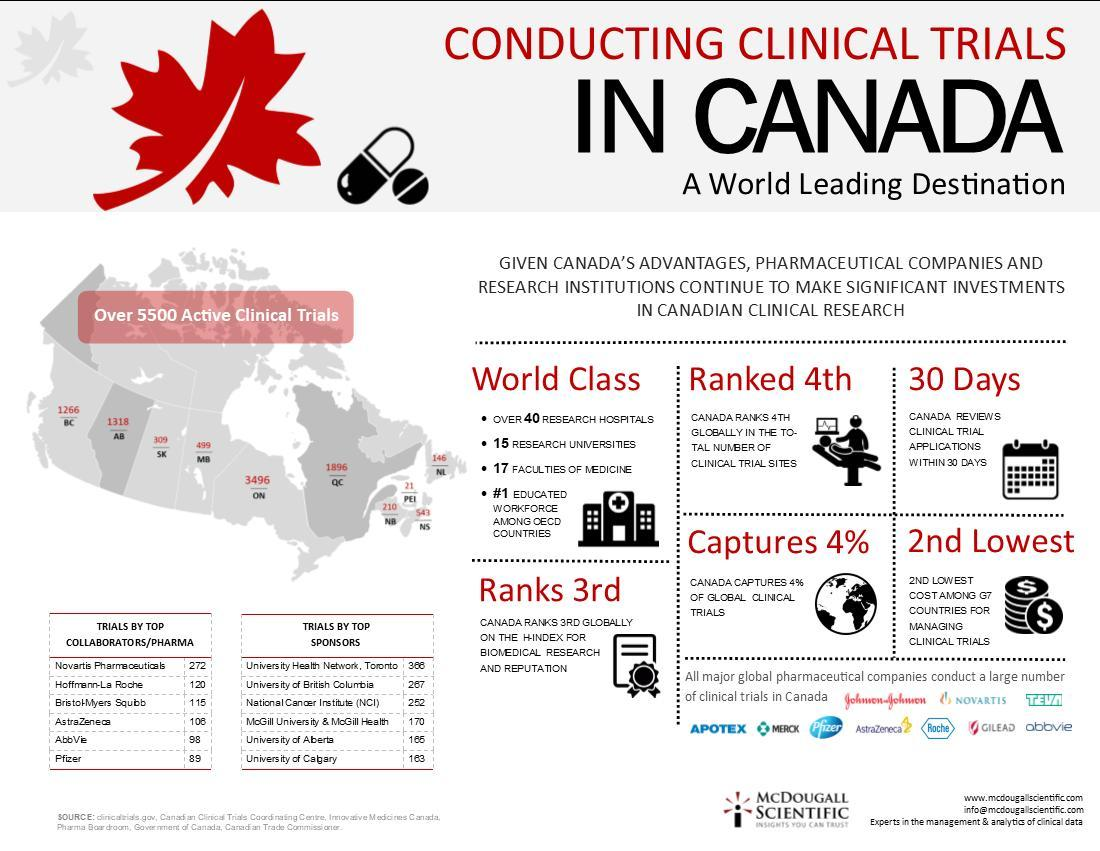How many active clinical trials are there in Alberta?
Answer the question with a short phrase. 1318 How many days it takes to review the clinical trial applications in Canada? WITHIN 30 DAYS How many active clinical trials are there in Quebec? 1896 Which Canadian province has the least number of active clinical trials - Manitoba, Ontario, Quebec or Prince Edward Island? PEI How many clinical trials were performed by the University of British Columbia? 267 What percent of the global clinical trials were done in Canada? 4% Which Canadian province has the highest number of active clinical trials - Manitoba, Ontario, Quebec or British Columbia? Ontario How many clinical trials were performed by the University of Alberta? 165 How many active clinical trials are there in Manitoba? 499 